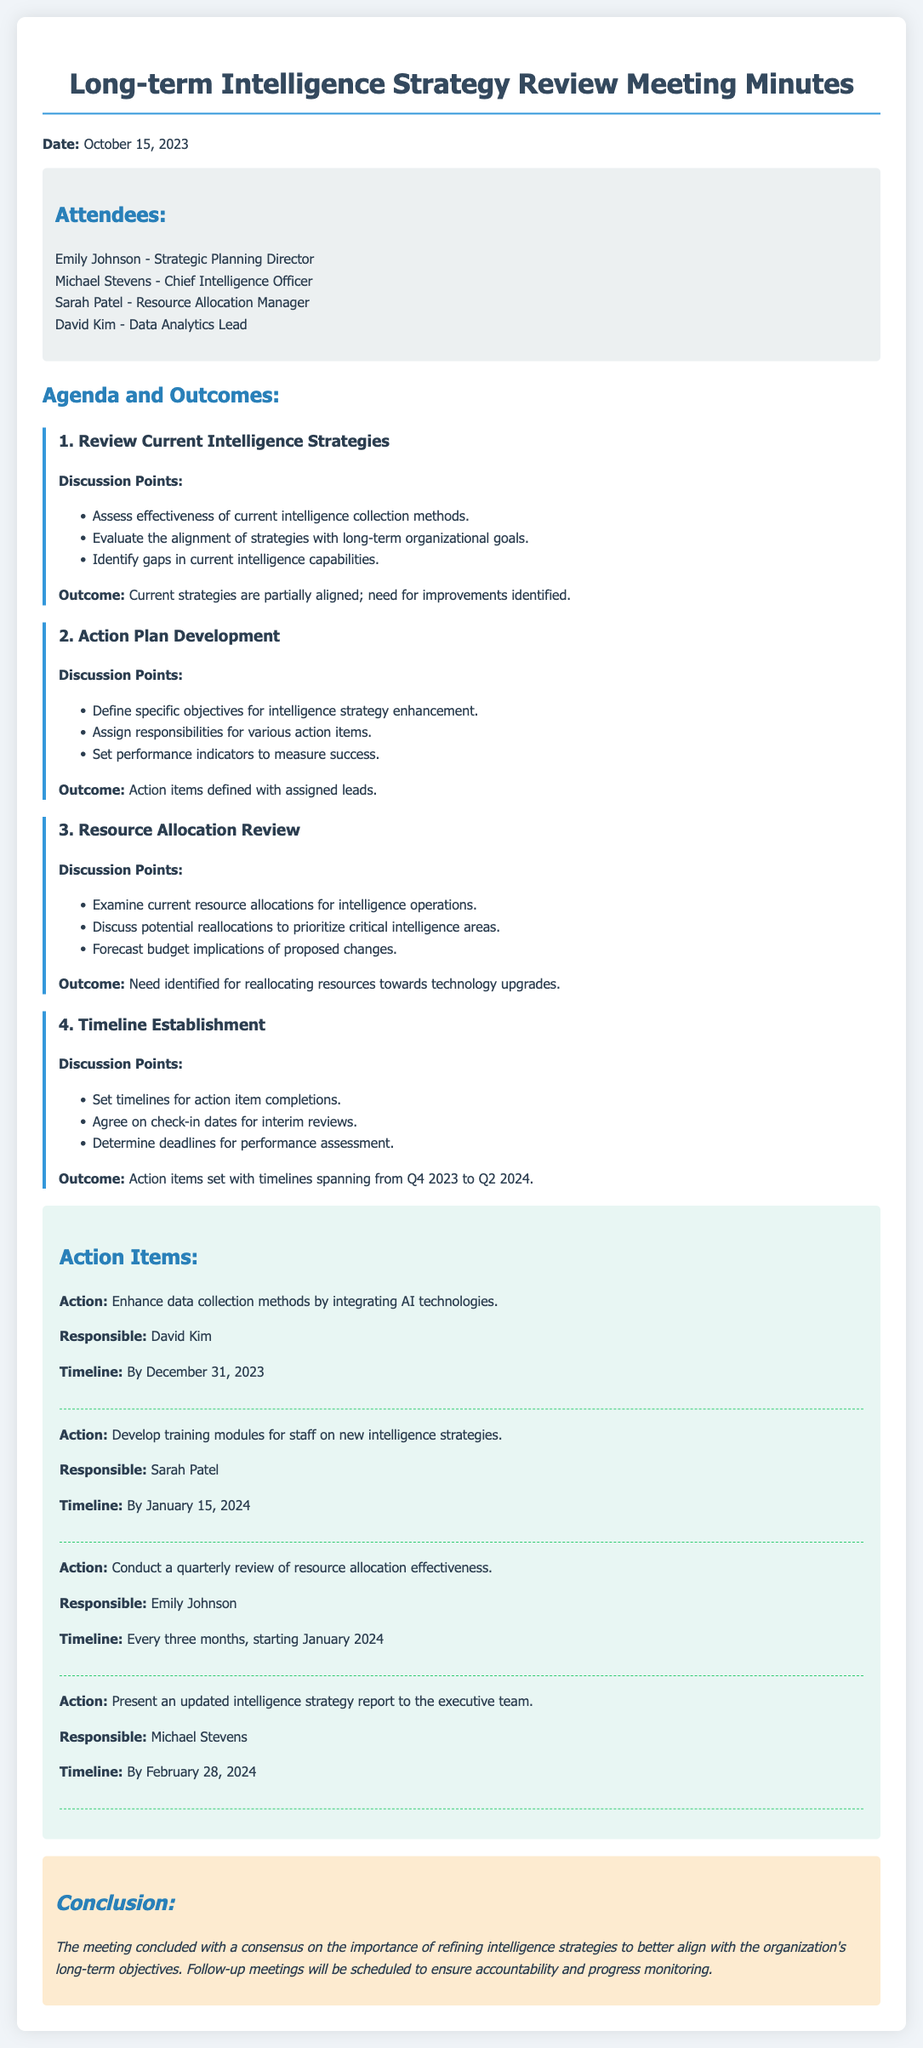what is the date of the meeting? The meeting was held on October 15, 2023, as stated in the document.
Answer: October 15, 2023 who is responsible for enhancing data collection methods? The document specifies that David Kim is responsible for enhancing data collection methods.
Answer: David Kim what is the timeline for the training modules development? Sarah Patel is set to develop the training modules by January 15, 2024, according to the action items.
Answer: By January 15, 2024 how often will the quarterly review of resource allocation effectiveness occur? Emily Johnson is tasked with conducting quarterly reviews, which will take place every three months, as detailed in the document.
Answer: Every three months what was identified as a need in the resource allocation review? The document mentions a need for reallocating resources towards technology upgrades.
Answer: Reallocating resources towards technology upgrades which action item has the earliest deadline? The action item to enhance data collection methods has the earliest deadline of December 31, 2023, as per the timeline.
Answer: By December 31, 2023 how many attendees were present at the meeting? The document lists four attendees in the attendees section.
Answer: Four what is the overall conclusion from the meeting? The conclusion emphasizes the importance of refining intelligence strategies to align with long-term objectives.
Answer: Refining intelligence strategies what type of strategies were reviewed during the meeting? The discussion focused on reviewing current intelligence strategies, pertaining to their effectiveness and alignment.
Answer: Current intelligence strategies 